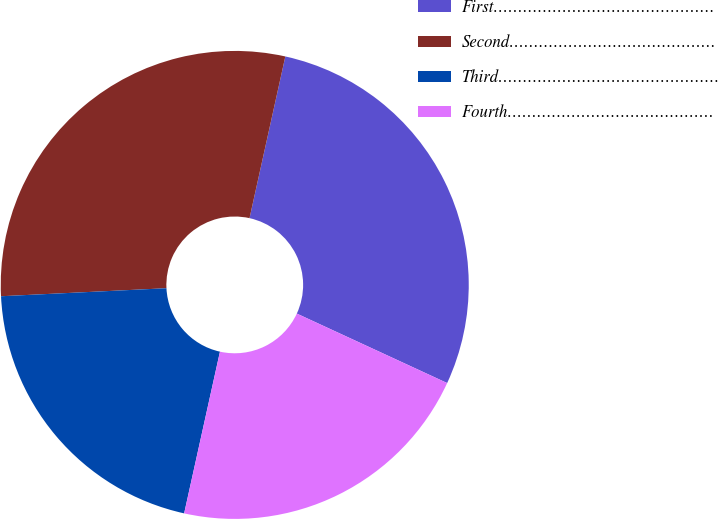Convert chart. <chart><loc_0><loc_0><loc_500><loc_500><pie_chart><fcel>First………………………………………<fcel>Second……………………………………<fcel>Third………………………………………<fcel>Fourth……………………………………<nl><fcel>28.42%<fcel>29.24%<fcel>20.76%<fcel>21.58%<nl></chart> 